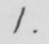Can you read and transcribe this handwriting? 1 . 